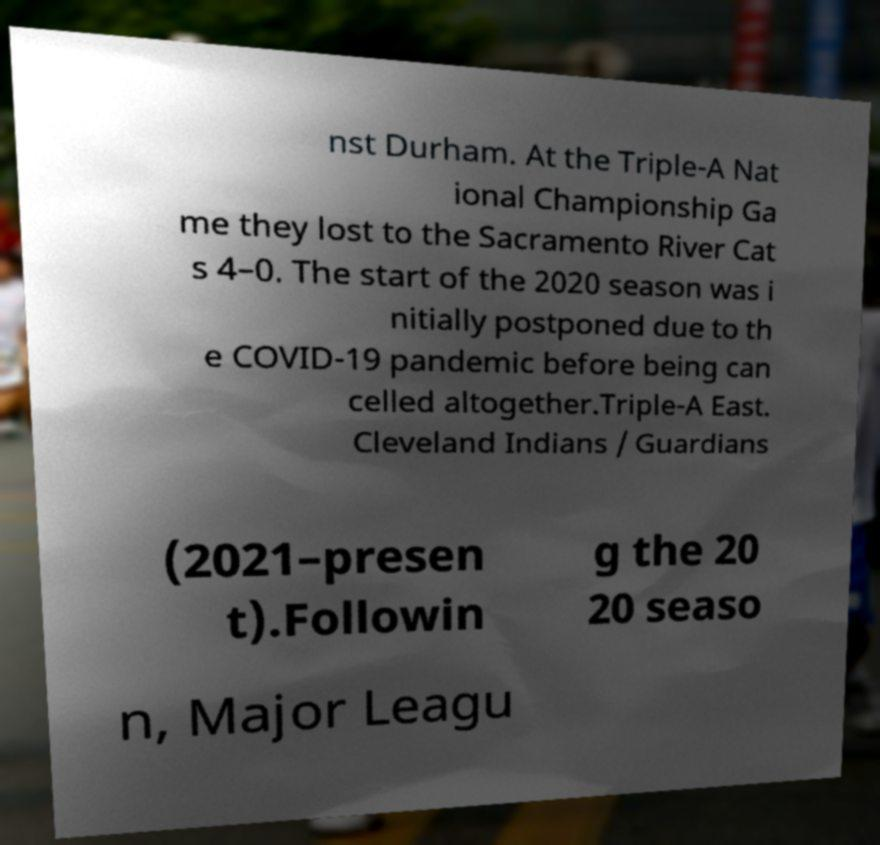I need the written content from this picture converted into text. Can you do that? nst Durham. At the Triple-A Nat ional Championship Ga me they lost to the Sacramento River Cat s 4–0. The start of the 2020 season was i nitially postponed due to th e COVID-19 pandemic before being can celled altogether.Triple-A East. Cleveland Indians / Guardians (2021–presen t).Followin g the 20 20 seaso n, Major Leagu 